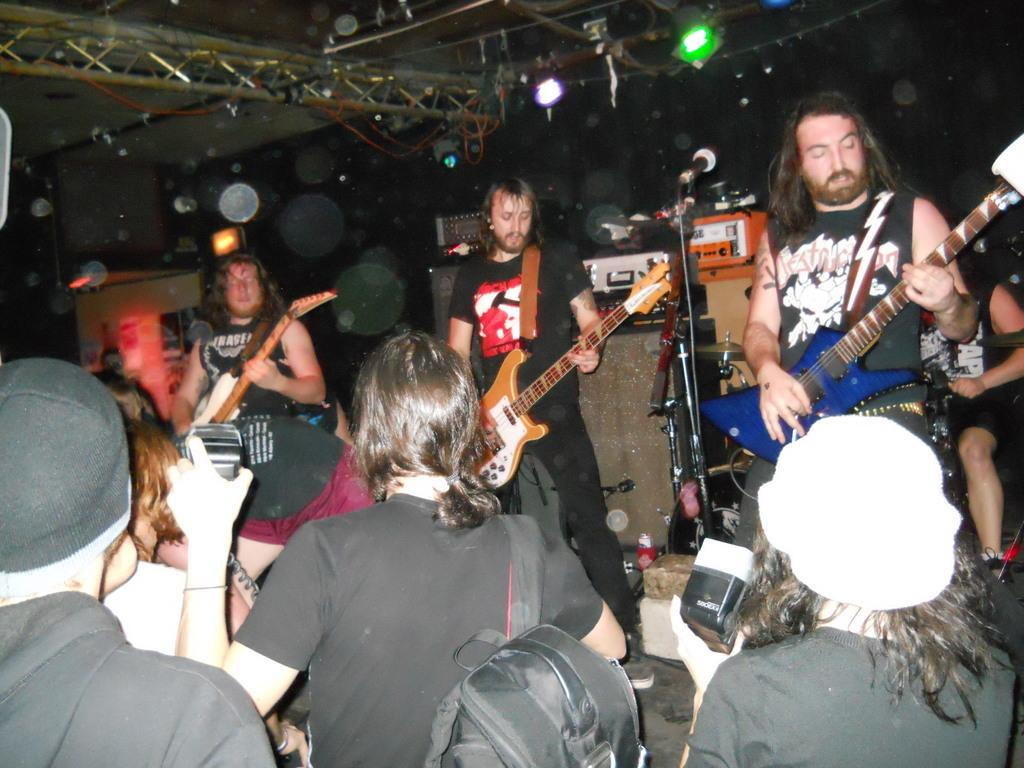What can be seen in the image? There are people in the image. What are the people holding in their hands? The people are holding guitars in their hands. What type of polish is being applied to the guitars in the image? There is no indication in the image that any polish is being applied to the guitars. How many people are slipping on the floor while playing the guitars in the image? There is no indication in the image that anyone is slipping on the floor while playing the guitars. 